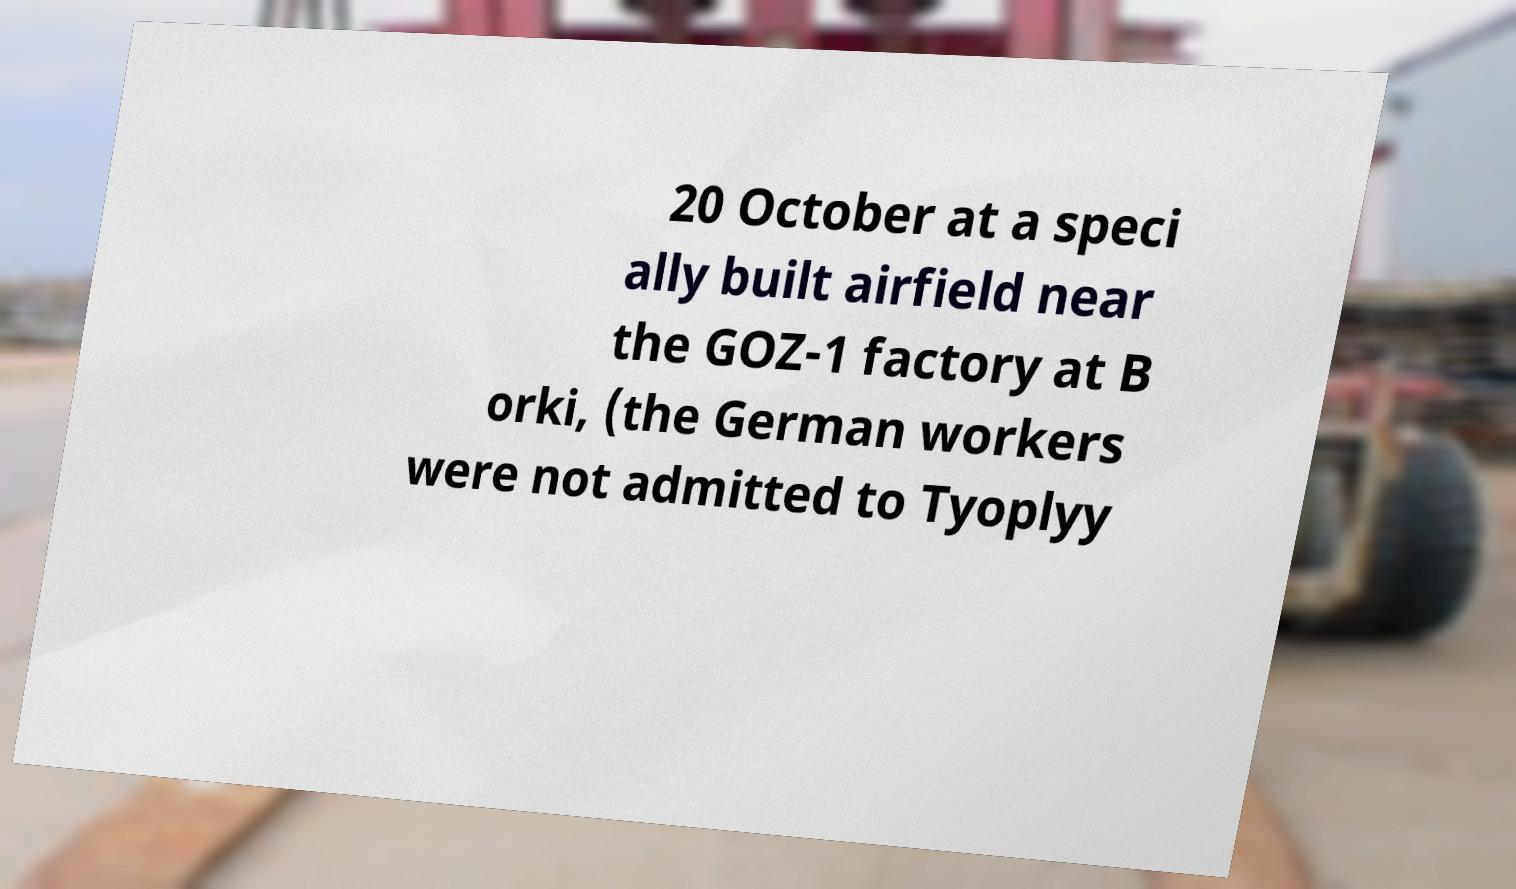What messages or text are displayed in this image? I need them in a readable, typed format. 20 October at a speci ally built airfield near the GOZ-1 factory at B orki, (the German workers were not admitted to Tyoplyy 